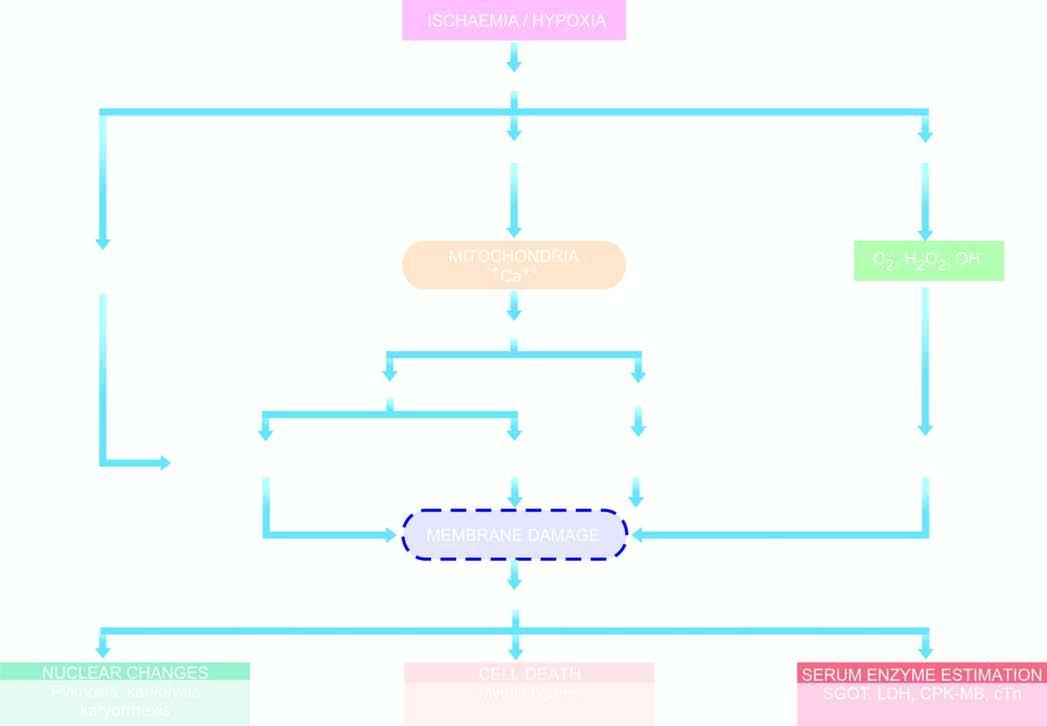how is sequence of events in the pathogenesis of reversible and irreversible cell injury caused?
Answer the question using a single word or phrase. By hypoxia/ischaemia 